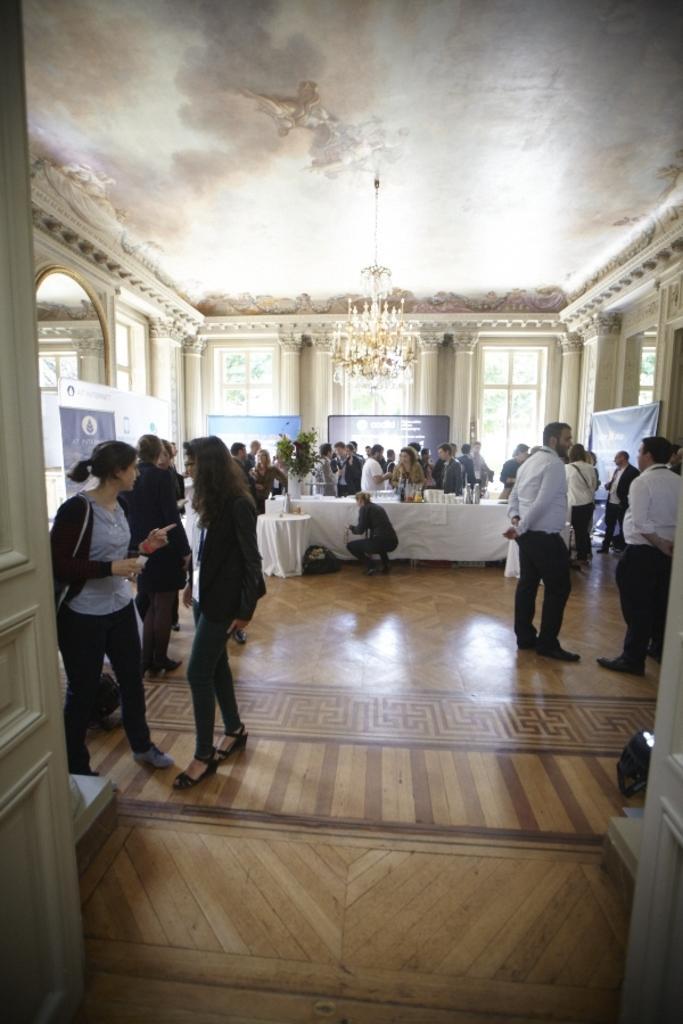Please provide a concise description of this image. In this image we can see there are people standing and holding a cover and bottle. And there is a table with a cloth, on the table there are cups, jar, glasses and few objects. At the back there are banners and windows. At the top there is a chandelier. 